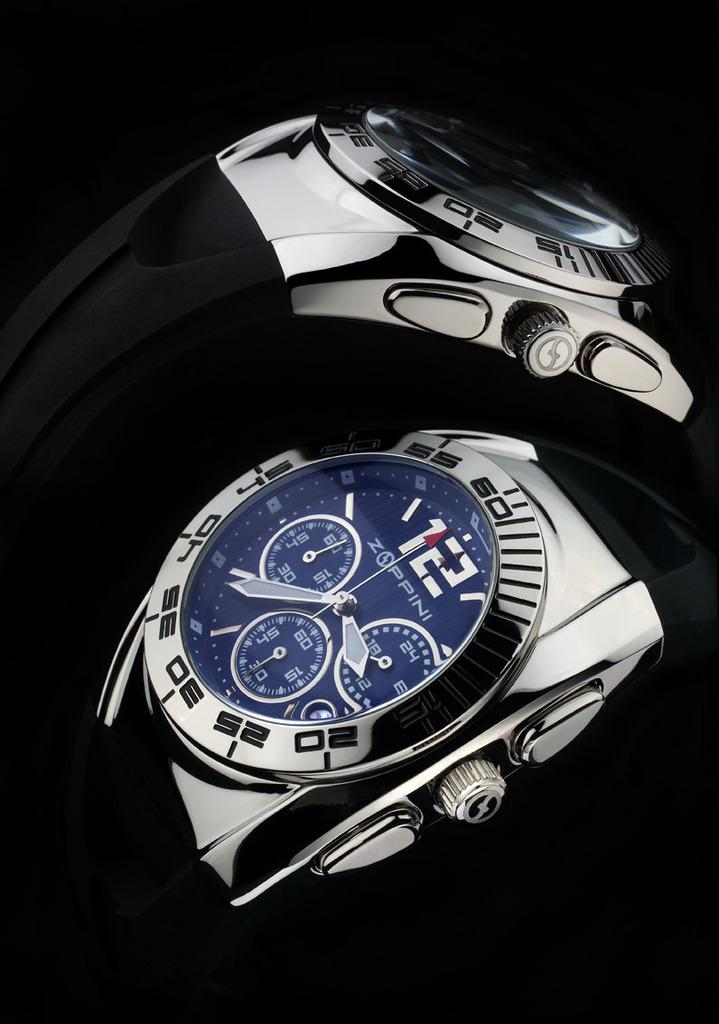<image>
Present a compact description of the photo's key features. the top and side views of a Zoppini mechanical watch with blue face 